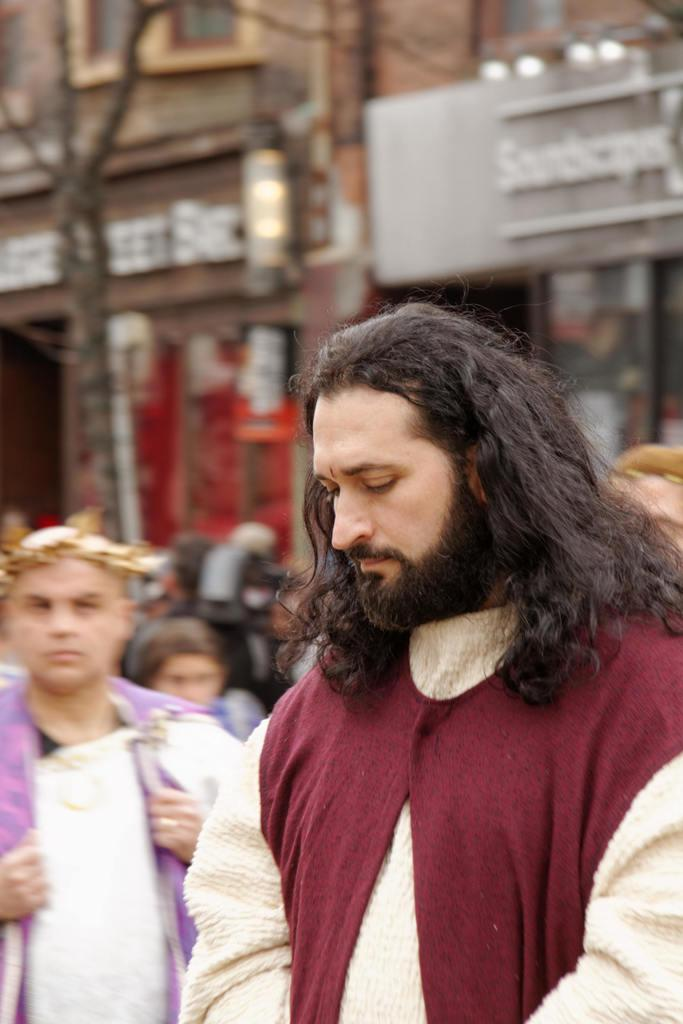How many people are in the image? There is a group of people in the image. Can you describe the attire of one of the individuals? One person is wearing a cream and maroon color dress. What can be seen in the background of the image? There are buildings in the background of the image. What colors are the buildings in the image? The buildings are in brown and gray colors. How many tomatoes are being used as decorations in the image? There are no tomatoes present in the image. What is the limit of the group of people in the image? There is no mention of a limit or restriction on the group of people in the image. 